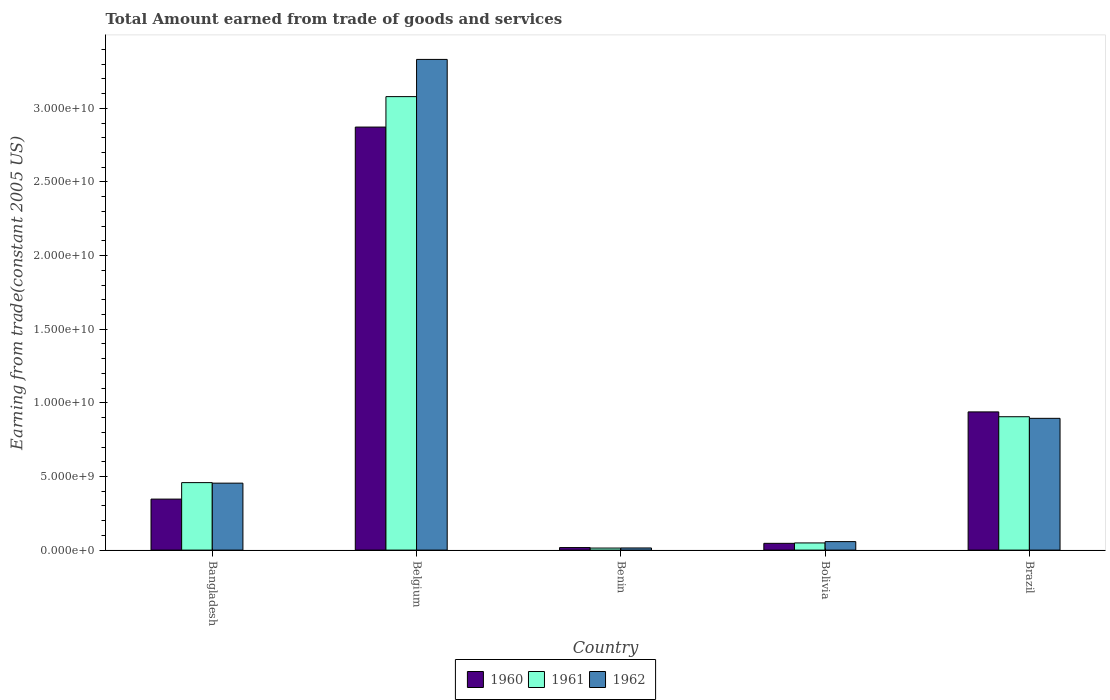How many different coloured bars are there?
Offer a very short reply. 3. Are the number of bars per tick equal to the number of legend labels?
Your answer should be compact. Yes. How many bars are there on the 1st tick from the right?
Offer a very short reply. 3. What is the label of the 2nd group of bars from the left?
Make the answer very short. Belgium. In how many cases, is the number of bars for a given country not equal to the number of legend labels?
Provide a succinct answer. 0. What is the total amount earned by trading goods and services in 1960 in Belgium?
Offer a very short reply. 2.87e+1. Across all countries, what is the maximum total amount earned by trading goods and services in 1960?
Provide a short and direct response. 2.87e+1. Across all countries, what is the minimum total amount earned by trading goods and services in 1961?
Your answer should be compact. 1.39e+08. In which country was the total amount earned by trading goods and services in 1960 maximum?
Make the answer very short. Belgium. In which country was the total amount earned by trading goods and services in 1962 minimum?
Your answer should be compact. Benin. What is the total total amount earned by trading goods and services in 1962 in the graph?
Offer a very short reply. 4.75e+1. What is the difference between the total amount earned by trading goods and services in 1961 in Benin and that in Bolivia?
Provide a short and direct response. -3.48e+08. What is the difference between the total amount earned by trading goods and services in 1960 in Benin and the total amount earned by trading goods and services in 1961 in Brazil?
Offer a terse response. -8.89e+09. What is the average total amount earned by trading goods and services in 1960 per country?
Your response must be concise. 8.44e+09. What is the difference between the total amount earned by trading goods and services of/in 1960 and total amount earned by trading goods and services of/in 1962 in Brazil?
Make the answer very short. 4.36e+08. In how many countries, is the total amount earned by trading goods and services in 1962 greater than 18000000000 US$?
Your answer should be very brief. 1. What is the ratio of the total amount earned by trading goods and services in 1960 in Belgium to that in Brazil?
Your response must be concise. 3.06. What is the difference between the highest and the second highest total amount earned by trading goods and services in 1960?
Your response must be concise. 1.93e+1. What is the difference between the highest and the lowest total amount earned by trading goods and services in 1961?
Your response must be concise. 3.07e+1. Is it the case that in every country, the sum of the total amount earned by trading goods and services in 1960 and total amount earned by trading goods and services in 1961 is greater than the total amount earned by trading goods and services in 1962?
Make the answer very short. Yes. How many bars are there?
Provide a short and direct response. 15. Are all the bars in the graph horizontal?
Your answer should be compact. No. How many countries are there in the graph?
Give a very brief answer. 5. Are the values on the major ticks of Y-axis written in scientific E-notation?
Give a very brief answer. Yes. Does the graph contain grids?
Your answer should be very brief. No. Where does the legend appear in the graph?
Your response must be concise. Bottom center. How many legend labels are there?
Give a very brief answer. 3. How are the legend labels stacked?
Ensure brevity in your answer.  Horizontal. What is the title of the graph?
Make the answer very short. Total Amount earned from trade of goods and services. What is the label or title of the X-axis?
Provide a short and direct response. Country. What is the label or title of the Y-axis?
Keep it short and to the point. Earning from trade(constant 2005 US). What is the Earning from trade(constant 2005 US) in 1960 in Bangladesh?
Provide a succinct answer. 3.46e+09. What is the Earning from trade(constant 2005 US) of 1961 in Bangladesh?
Provide a short and direct response. 4.58e+09. What is the Earning from trade(constant 2005 US) of 1962 in Bangladesh?
Provide a short and direct response. 4.55e+09. What is the Earning from trade(constant 2005 US) of 1960 in Belgium?
Your answer should be very brief. 2.87e+1. What is the Earning from trade(constant 2005 US) in 1961 in Belgium?
Your answer should be very brief. 3.08e+1. What is the Earning from trade(constant 2005 US) of 1962 in Belgium?
Your answer should be compact. 3.33e+1. What is the Earning from trade(constant 2005 US) in 1960 in Benin?
Offer a very short reply. 1.71e+08. What is the Earning from trade(constant 2005 US) of 1961 in Benin?
Ensure brevity in your answer.  1.39e+08. What is the Earning from trade(constant 2005 US) in 1962 in Benin?
Provide a short and direct response. 1.45e+08. What is the Earning from trade(constant 2005 US) of 1960 in Bolivia?
Give a very brief answer. 4.60e+08. What is the Earning from trade(constant 2005 US) in 1961 in Bolivia?
Offer a very short reply. 4.87e+08. What is the Earning from trade(constant 2005 US) of 1962 in Bolivia?
Your response must be concise. 5.76e+08. What is the Earning from trade(constant 2005 US) in 1960 in Brazil?
Your answer should be compact. 9.39e+09. What is the Earning from trade(constant 2005 US) in 1961 in Brazil?
Your answer should be very brief. 9.06e+09. What is the Earning from trade(constant 2005 US) of 1962 in Brazil?
Provide a short and direct response. 8.95e+09. Across all countries, what is the maximum Earning from trade(constant 2005 US) in 1960?
Ensure brevity in your answer.  2.87e+1. Across all countries, what is the maximum Earning from trade(constant 2005 US) in 1961?
Provide a short and direct response. 3.08e+1. Across all countries, what is the maximum Earning from trade(constant 2005 US) of 1962?
Provide a short and direct response. 3.33e+1. Across all countries, what is the minimum Earning from trade(constant 2005 US) in 1960?
Your answer should be very brief. 1.71e+08. Across all countries, what is the minimum Earning from trade(constant 2005 US) in 1961?
Give a very brief answer. 1.39e+08. Across all countries, what is the minimum Earning from trade(constant 2005 US) in 1962?
Provide a short and direct response. 1.45e+08. What is the total Earning from trade(constant 2005 US) in 1960 in the graph?
Offer a terse response. 4.22e+1. What is the total Earning from trade(constant 2005 US) of 1961 in the graph?
Your answer should be very brief. 4.51e+1. What is the total Earning from trade(constant 2005 US) in 1962 in the graph?
Provide a short and direct response. 4.75e+1. What is the difference between the Earning from trade(constant 2005 US) of 1960 in Bangladesh and that in Belgium?
Offer a very short reply. -2.53e+1. What is the difference between the Earning from trade(constant 2005 US) of 1961 in Bangladesh and that in Belgium?
Keep it short and to the point. -2.62e+1. What is the difference between the Earning from trade(constant 2005 US) of 1962 in Bangladesh and that in Belgium?
Offer a terse response. -2.88e+1. What is the difference between the Earning from trade(constant 2005 US) in 1960 in Bangladesh and that in Benin?
Offer a terse response. 3.29e+09. What is the difference between the Earning from trade(constant 2005 US) in 1961 in Bangladesh and that in Benin?
Your answer should be very brief. 4.44e+09. What is the difference between the Earning from trade(constant 2005 US) of 1962 in Bangladesh and that in Benin?
Offer a terse response. 4.40e+09. What is the difference between the Earning from trade(constant 2005 US) of 1960 in Bangladesh and that in Bolivia?
Your response must be concise. 3.00e+09. What is the difference between the Earning from trade(constant 2005 US) of 1961 in Bangladesh and that in Bolivia?
Your answer should be compact. 4.10e+09. What is the difference between the Earning from trade(constant 2005 US) in 1962 in Bangladesh and that in Bolivia?
Offer a terse response. 3.97e+09. What is the difference between the Earning from trade(constant 2005 US) of 1960 in Bangladesh and that in Brazil?
Offer a very short reply. -5.92e+09. What is the difference between the Earning from trade(constant 2005 US) of 1961 in Bangladesh and that in Brazil?
Offer a terse response. -4.48e+09. What is the difference between the Earning from trade(constant 2005 US) of 1962 in Bangladesh and that in Brazil?
Your answer should be very brief. -4.40e+09. What is the difference between the Earning from trade(constant 2005 US) in 1960 in Belgium and that in Benin?
Offer a terse response. 2.86e+1. What is the difference between the Earning from trade(constant 2005 US) of 1961 in Belgium and that in Benin?
Give a very brief answer. 3.07e+1. What is the difference between the Earning from trade(constant 2005 US) of 1962 in Belgium and that in Benin?
Provide a succinct answer. 3.32e+1. What is the difference between the Earning from trade(constant 2005 US) in 1960 in Belgium and that in Bolivia?
Your response must be concise. 2.83e+1. What is the difference between the Earning from trade(constant 2005 US) of 1961 in Belgium and that in Bolivia?
Make the answer very short. 3.03e+1. What is the difference between the Earning from trade(constant 2005 US) in 1962 in Belgium and that in Bolivia?
Your response must be concise. 3.27e+1. What is the difference between the Earning from trade(constant 2005 US) in 1960 in Belgium and that in Brazil?
Your response must be concise. 1.93e+1. What is the difference between the Earning from trade(constant 2005 US) of 1961 in Belgium and that in Brazil?
Ensure brevity in your answer.  2.17e+1. What is the difference between the Earning from trade(constant 2005 US) in 1962 in Belgium and that in Brazil?
Offer a very short reply. 2.44e+1. What is the difference between the Earning from trade(constant 2005 US) of 1960 in Benin and that in Bolivia?
Give a very brief answer. -2.88e+08. What is the difference between the Earning from trade(constant 2005 US) of 1961 in Benin and that in Bolivia?
Ensure brevity in your answer.  -3.48e+08. What is the difference between the Earning from trade(constant 2005 US) of 1962 in Benin and that in Bolivia?
Provide a succinct answer. -4.31e+08. What is the difference between the Earning from trade(constant 2005 US) in 1960 in Benin and that in Brazil?
Offer a terse response. -9.21e+09. What is the difference between the Earning from trade(constant 2005 US) in 1961 in Benin and that in Brazil?
Your answer should be very brief. -8.92e+09. What is the difference between the Earning from trade(constant 2005 US) of 1962 in Benin and that in Brazil?
Your response must be concise. -8.80e+09. What is the difference between the Earning from trade(constant 2005 US) of 1960 in Bolivia and that in Brazil?
Provide a short and direct response. -8.93e+09. What is the difference between the Earning from trade(constant 2005 US) of 1961 in Bolivia and that in Brazil?
Your answer should be compact. -8.57e+09. What is the difference between the Earning from trade(constant 2005 US) in 1962 in Bolivia and that in Brazil?
Ensure brevity in your answer.  -8.37e+09. What is the difference between the Earning from trade(constant 2005 US) in 1960 in Bangladesh and the Earning from trade(constant 2005 US) in 1961 in Belgium?
Your answer should be very brief. -2.73e+1. What is the difference between the Earning from trade(constant 2005 US) of 1960 in Bangladesh and the Earning from trade(constant 2005 US) of 1962 in Belgium?
Keep it short and to the point. -2.99e+1. What is the difference between the Earning from trade(constant 2005 US) of 1961 in Bangladesh and the Earning from trade(constant 2005 US) of 1962 in Belgium?
Provide a succinct answer. -2.87e+1. What is the difference between the Earning from trade(constant 2005 US) of 1960 in Bangladesh and the Earning from trade(constant 2005 US) of 1961 in Benin?
Make the answer very short. 3.32e+09. What is the difference between the Earning from trade(constant 2005 US) of 1960 in Bangladesh and the Earning from trade(constant 2005 US) of 1962 in Benin?
Provide a short and direct response. 3.32e+09. What is the difference between the Earning from trade(constant 2005 US) in 1961 in Bangladesh and the Earning from trade(constant 2005 US) in 1962 in Benin?
Offer a very short reply. 4.44e+09. What is the difference between the Earning from trade(constant 2005 US) of 1960 in Bangladesh and the Earning from trade(constant 2005 US) of 1961 in Bolivia?
Keep it short and to the point. 2.98e+09. What is the difference between the Earning from trade(constant 2005 US) in 1960 in Bangladesh and the Earning from trade(constant 2005 US) in 1962 in Bolivia?
Give a very brief answer. 2.89e+09. What is the difference between the Earning from trade(constant 2005 US) in 1961 in Bangladesh and the Earning from trade(constant 2005 US) in 1962 in Bolivia?
Your response must be concise. 4.01e+09. What is the difference between the Earning from trade(constant 2005 US) in 1960 in Bangladesh and the Earning from trade(constant 2005 US) in 1961 in Brazil?
Ensure brevity in your answer.  -5.59e+09. What is the difference between the Earning from trade(constant 2005 US) of 1960 in Bangladesh and the Earning from trade(constant 2005 US) of 1962 in Brazil?
Provide a succinct answer. -5.49e+09. What is the difference between the Earning from trade(constant 2005 US) of 1961 in Bangladesh and the Earning from trade(constant 2005 US) of 1962 in Brazil?
Give a very brief answer. -4.37e+09. What is the difference between the Earning from trade(constant 2005 US) in 1960 in Belgium and the Earning from trade(constant 2005 US) in 1961 in Benin?
Make the answer very short. 2.86e+1. What is the difference between the Earning from trade(constant 2005 US) in 1960 in Belgium and the Earning from trade(constant 2005 US) in 1962 in Benin?
Your answer should be very brief. 2.86e+1. What is the difference between the Earning from trade(constant 2005 US) in 1961 in Belgium and the Earning from trade(constant 2005 US) in 1962 in Benin?
Keep it short and to the point. 3.07e+1. What is the difference between the Earning from trade(constant 2005 US) in 1960 in Belgium and the Earning from trade(constant 2005 US) in 1961 in Bolivia?
Provide a short and direct response. 2.82e+1. What is the difference between the Earning from trade(constant 2005 US) of 1960 in Belgium and the Earning from trade(constant 2005 US) of 1962 in Bolivia?
Provide a short and direct response. 2.82e+1. What is the difference between the Earning from trade(constant 2005 US) in 1961 in Belgium and the Earning from trade(constant 2005 US) in 1962 in Bolivia?
Make the answer very short. 3.02e+1. What is the difference between the Earning from trade(constant 2005 US) in 1960 in Belgium and the Earning from trade(constant 2005 US) in 1961 in Brazil?
Your answer should be very brief. 1.97e+1. What is the difference between the Earning from trade(constant 2005 US) in 1960 in Belgium and the Earning from trade(constant 2005 US) in 1962 in Brazil?
Give a very brief answer. 1.98e+1. What is the difference between the Earning from trade(constant 2005 US) in 1961 in Belgium and the Earning from trade(constant 2005 US) in 1962 in Brazil?
Ensure brevity in your answer.  2.18e+1. What is the difference between the Earning from trade(constant 2005 US) in 1960 in Benin and the Earning from trade(constant 2005 US) in 1961 in Bolivia?
Provide a short and direct response. -3.15e+08. What is the difference between the Earning from trade(constant 2005 US) in 1960 in Benin and the Earning from trade(constant 2005 US) in 1962 in Bolivia?
Your answer should be very brief. -4.05e+08. What is the difference between the Earning from trade(constant 2005 US) in 1961 in Benin and the Earning from trade(constant 2005 US) in 1962 in Bolivia?
Provide a short and direct response. -4.38e+08. What is the difference between the Earning from trade(constant 2005 US) in 1960 in Benin and the Earning from trade(constant 2005 US) in 1961 in Brazil?
Your answer should be compact. -8.89e+09. What is the difference between the Earning from trade(constant 2005 US) of 1960 in Benin and the Earning from trade(constant 2005 US) of 1962 in Brazil?
Make the answer very short. -8.78e+09. What is the difference between the Earning from trade(constant 2005 US) in 1961 in Benin and the Earning from trade(constant 2005 US) in 1962 in Brazil?
Give a very brief answer. -8.81e+09. What is the difference between the Earning from trade(constant 2005 US) in 1960 in Bolivia and the Earning from trade(constant 2005 US) in 1961 in Brazil?
Ensure brevity in your answer.  -8.60e+09. What is the difference between the Earning from trade(constant 2005 US) of 1960 in Bolivia and the Earning from trade(constant 2005 US) of 1962 in Brazil?
Your response must be concise. -8.49e+09. What is the difference between the Earning from trade(constant 2005 US) of 1961 in Bolivia and the Earning from trade(constant 2005 US) of 1962 in Brazil?
Offer a very short reply. -8.46e+09. What is the average Earning from trade(constant 2005 US) in 1960 per country?
Your answer should be very brief. 8.44e+09. What is the average Earning from trade(constant 2005 US) of 1961 per country?
Make the answer very short. 9.01e+09. What is the average Earning from trade(constant 2005 US) of 1962 per country?
Offer a very short reply. 9.51e+09. What is the difference between the Earning from trade(constant 2005 US) in 1960 and Earning from trade(constant 2005 US) in 1961 in Bangladesh?
Give a very brief answer. -1.12e+09. What is the difference between the Earning from trade(constant 2005 US) of 1960 and Earning from trade(constant 2005 US) of 1962 in Bangladesh?
Provide a succinct answer. -1.08e+09. What is the difference between the Earning from trade(constant 2005 US) of 1961 and Earning from trade(constant 2005 US) of 1962 in Bangladesh?
Provide a short and direct response. 3.53e+07. What is the difference between the Earning from trade(constant 2005 US) in 1960 and Earning from trade(constant 2005 US) in 1961 in Belgium?
Provide a short and direct response. -2.07e+09. What is the difference between the Earning from trade(constant 2005 US) in 1960 and Earning from trade(constant 2005 US) in 1962 in Belgium?
Your answer should be compact. -4.59e+09. What is the difference between the Earning from trade(constant 2005 US) of 1961 and Earning from trade(constant 2005 US) of 1962 in Belgium?
Your response must be concise. -2.53e+09. What is the difference between the Earning from trade(constant 2005 US) of 1960 and Earning from trade(constant 2005 US) of 1961 in Benin?
Offer a very short reply. 3.26e+07. What is the difference between the Earning from trade(constant 2005 US) in 1960 and Earning from trade(constant 2005 US) in 1962 in Benin?
Keep it short and to the point. 2.63e+07. What is the difference between the Earning from trade(constant 2005 US) in 1961 and Earning from trade(constant 2005 US) in 1962 in Benin?
Make the answer very short. -6.31e+06. What is the difference between the Earning from trade(constant 2005 US) in 1960 and Earning from trade(constant 2005 US) in 1961 in Bolivia?
Your answer should be very brief. -2.69e+07. What is the difference between the Earning from trade(constant 2005 US) in 1960 and Earning from trade(constant 2005 US) in 1962 in Bolivia?
Your answer should be compact. -1.17e+08. What is the difference between the Earning from trade(constant 2005 US) in 1961 and Earning from trade(constant 2005 US) in 1962 in Bolivia?
Keep it short and to the point. -8.97e+07. What is the difference between the Earning from trade(constant 2005 US) of 1960 and Earning from trade(constant 2005 US) of 1961 in Brazil?
Provide a short and direct response. 3.27e+08. What is the difference between the Earning from trade(constant 2005 US) in 1960 and Earning from trade(constant 2005 US) in 1962 in Brazil?
Ensure brevity in your answer.  4.36e+08. What is the difference between the Earning from trade(constant 2005 US) of 1961 and Earning from trade(constant 2005 US) of 1962 in Brazil?
Your answer should be compact. 1.09e+08. What is the ratio of the Earning from trade(constant 2005 US) in 1960 in Bangladesh to that in Belgium?
Offer a terse response. 0.12. What is the ratio of the Earning from trade(constant 2005 US) of 1961 in Bangladesh to that in Belgium?
Your answer should be compact. 0.15. What is the ratio of the Earning from trade(constant 2005 US) in 1962 in Bangladesh to that in Belgium?
Your response must be concise. 0.14. What is the ratio of the Earning from trade(constant 2005 US) in 1960 in Bangladesh to that in Benin?
Ensure brevity in your answer.  20.21. What is the ratio of the Earning from trade(constant 2005 US) of 1961 in Bangladesh to that in Benin?
Keep it short and to the point. 33.02. What is the ratio of the Earning from trade(constant 2005 US) in 1962 in Bangladesh to that in Benin?
Provide a succinct answer. 31.34. What is the ratio of the Earning from trade(constant 2005 US) of 1960 in Bangladesh to that in Bolivia?
Provide a short and direct response. 7.53. What is the ratio of the Earning from trade(constant 2005 US) in 1961 in Bangladesh to that in Bolivia?
Your answer should be compact. 9.42. What is the ratio of the Earning from trade(constant 2005 US) of 1962 in Bangladesh to that in Bolivia?
Your answer should be very brief. 7.89. What is the ratio of the Earning from trade(constant 2005 US) in 1960 in Bangladesh to that in Brazil?
Provide a short and direct response. 0.37. What is the ratio of the Earning from trade(constant 2005 US) of 1961 in Bangladesh to that in Brazil?
Offer a terse response. 0.51. What is the ratio of the Earning from trade(constant 2005 US) of 1962 in Bangladesh to that in Brazil?
Your response must be concise. 0.51. What is the ratio of the Earning from trade(constant 2005 US) in 1960 in Belgium to that in Benin?
Ensure brevity in your answer.  167.64. What is the ratio of the Earning from trade(constant 2005 US) in 1961 in Belgium to that in Benin?
Keep it short and to the point. 221.9. What is the ratio of the Earning from trade(constant 2005 US) in 1962 in Belgium to that in Benin?
Provide a short and direct response. 229.68. What is the ratio of the Earning from trade(constant 2005 US) in 1960 in Belgium to that in Bolivia?
Provide a short and direct response. 62.48. What is the ratio of the Earning from trade(constant 2005 US) in 1961 in Belgium to that in Bolivia?
Make the answer very short. 63.27. What is the ratio of the Earning from trade(constant 2005 US) of 1962 in Belgium to that in Bolivia?
Provide a succinct answer. 57.81. What is the ratio of the Earning from trade(constant 2005 US) in 1960 in Belgium to that in Brazil?
Offer a terse response. 3.06. What is the ratio of the Earning from trade(constant 2005 US) of 1961 in Belgium to that in Brazil?
Offer a terse response. 3.4. What is the ratio of the Earning from trade(constant 2005 US) in 1962 in Belgium to that in Brazil?
Make the answer very short. 3.72. What is the ratio of the Earning from trade(constant 2005 US) in 1960 in Benin to that in Bolivia?
Give a very brief answer. 0.37. What is the ratio of the Earning from trade(constant 2005 US) of 1961 in Benin to that in Bolivia?
Give a very brief answer. 0.29. What is the ratio of the Earning from trade(constant 2005 US) of 1962 in Benin to that in Bolivia?
Your answer should be compact. 0.25. What is the ratio of the Earning from trade(constant 2005 US) of 1960 in Benin to that in Brazil?
Your answer should be compact. 0.02. What is the ratio of the Earning from trade(constant 2005 US) in 1961 in Benin to that in Brazil?
Offer a very short reply. 0.02. What is the ratio of the Earning from trade(constant 2005 US) in 1962 in Benin to that in Brazil?
Ensure brevity in your answer.  0.02. What is the ratio of the Earning from trade(constant 2005 US) in 1960 in Bolivia to that in Brazil?
Provide a short and direct response. 0.05. What is the ratio of the Earning from trade(constant 2005 US) of 1961 in Bolivia to that in Brazil?
Provide a succinct answer. 0.05. What is the ratio of the Earning from trade(constant 2005 US) of 1962 in Bolivia to that in Brazil?
Your answer should be very brief. 0.06. What is the difference between the highest and the second highest Earning from trade(constant 2005 US) in 1960?
Make the answer very short. 1.93e+1. What is the difference between the highest and the second highest Earning from trade(constant 2005 US) of 1961?
Make the answer very short. 2.17e+1. What is the difference between the highest and the second highest Earning from trade(constant 2005 US) in 1962?
Your response must be concise. 2.44e+1. What is the difference between the highest and the lowest Earning from trade(constant 2005 US) of 1960?
Your answer should be compact. 2.86e+1. What is the difference between the highest and the lowest Earning from trade(constant 2005 US) in 1961?
Make the answer very short. 3.07e+1. What is the difference between the highest and the lowest Earning from trade(constant 2005 US) in 1962?
Your response must be concise. 3.32e+1. 